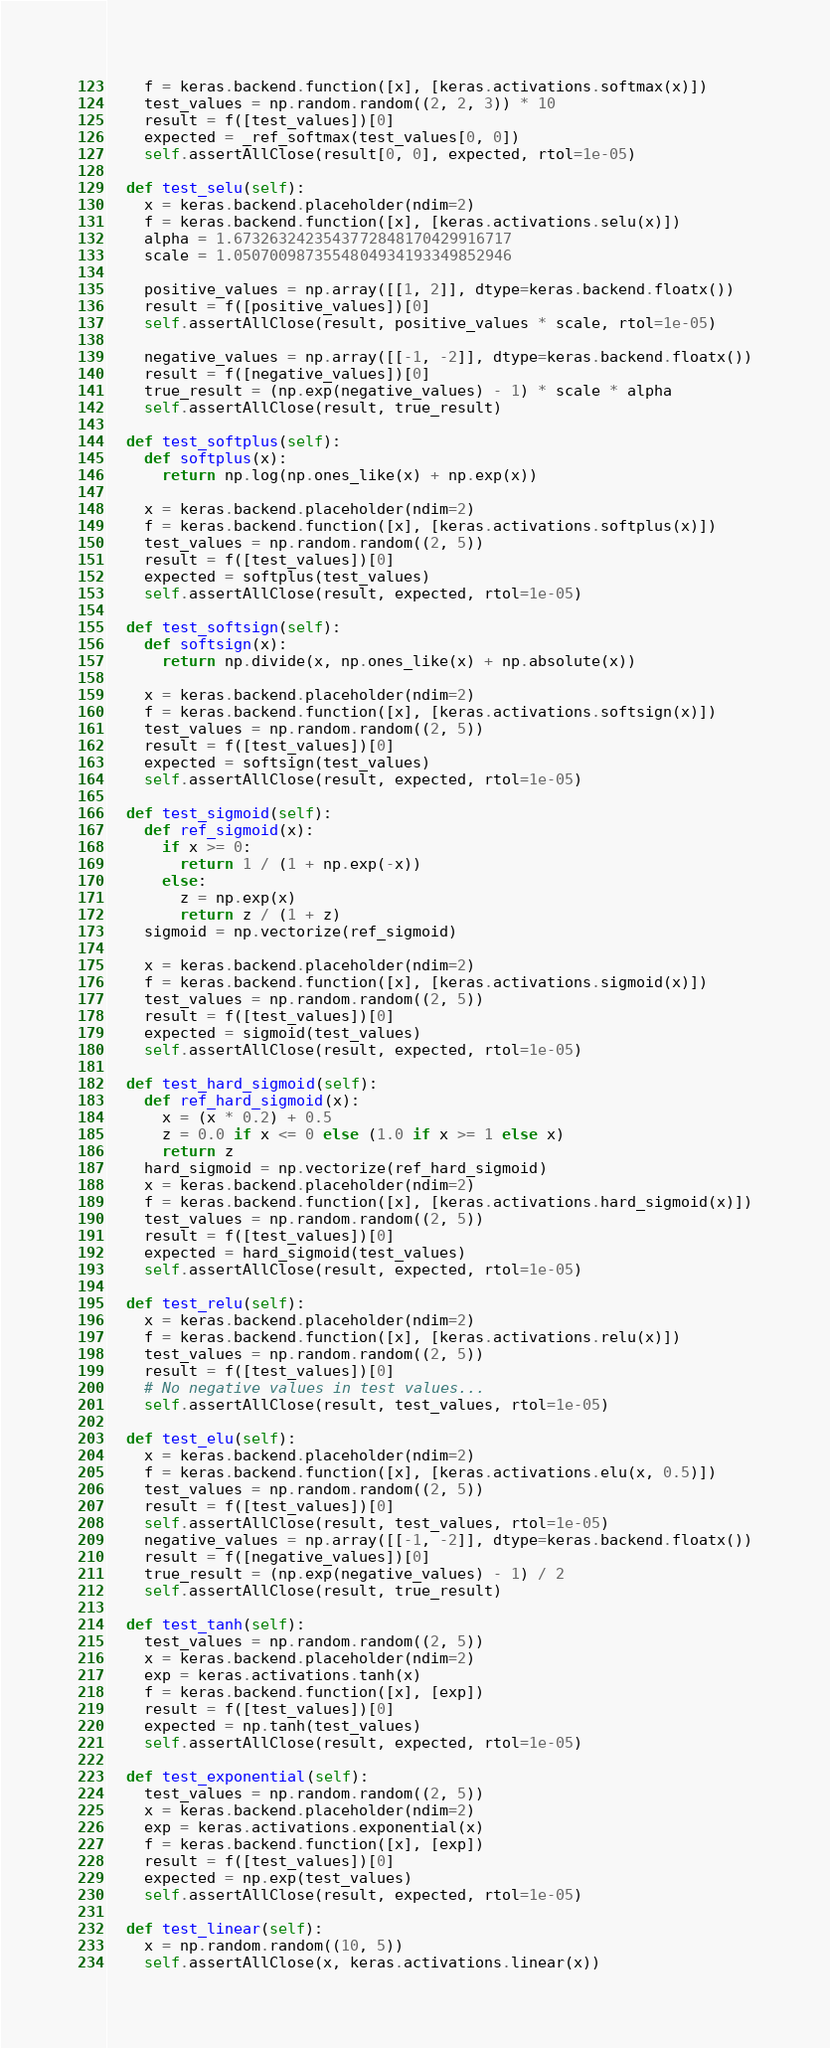Convert code to text. <code><loc_0><loc_0><loc_500><loc_500><_Python_>    f = keras.backend.function([x], [keras.activations.softmax(x)])
    test_values = np.random.random((2, 2, 3)) * 10
    result = f([test_values])[0]
    expected = _ref_softmax(test_values[0, 0])
    self.assertAllClose(result[0, 0], expected, rtol=1e-05)

  def test_selu(self):
    x = keras.backend.placeholder(ndim=2)
    f = keras.backend.function([x], [keras.activations.selu(x)])
    alpha = 1.6732632423543772848170429916717
    scale = 1.0507009873554804934193349852946

    positive_values = np.array([[1, 2]], dtype=keras.backend.floatx())
    result = f([positive_values])[0]
    self.assertAllClose(result, positive_values * scale, rtol=1e-05)

    negative_values = np.array([[-1, -2]], dtype=keras.backend.floatx())
    result = f([negative_values])[0]
    true_result = (np.exp(negative_values) - 1) * scale * alpha
    self.assertAllClose(result, true_result)

  def test_softplus(self):
    def softplus(x):
      return np.log(np.ones_like(x) + np.exp(x))

    x = keras.backend.placeholder(ndim=2)
    f = keras.backend.function([x], [keras.activations.softplus(x)])
    test_values = np.random.random((2, 5))
    result = f([test_values])[0]
    expected = softplus(test_values)
    self.assertAllClose(result, expected, rtol=1e-05)

  def test_softsign(self):
    def softsign(x):
      return np.divide(x, np.ones_like(x) + np.absolute(x))

    x = keras.backend.placeholder(ndim=2)
    f = keras.backend.function([x], [keras.activations.softsign(x)])
    test_values = np.random.random((2, 5))
    result = f([test_values])[0]
    expected = softsign(test_values)
    self.assertAllClose(result, expected, rtol=1e-05)

  def test_sigmoid(self):
    def ref_sigmoid(x):
      if x >= 0:
        return 1 / (1 + np.exp(-x))
      else:
        z = np.exp(x)
        return z / (1 + z)
    sigmoid = np.vectorize(ref_sigmoid)

    x = keras.backend.placeholder(ndim=2)
    f = keras.backend.function([x], [keras.activations.sigmoid(x)])
    test_values = np.random.random((2, 5))
    result = f([test_values])[0]
    expected = sigmoid(test_values)
    self.assertAllClose(result, expected, rtol=1e-05)

  def test_hard_sigmoid(self):
    def ref_hard_sigmoid(x):
      x = (x * 0.2) + 0.5
      z = 0.0 if x <= 0 else (1.0 if x >= 1 else x)
      return z
    hard_sigmoid = np.vectorize(ref_hard_sigmoid)
    x = keras.backend.placeholder(ndim=2)
    f = keras.backend.function([x], [keras.activations.hard_sigmoid(x)])
    test_values = np.random.random((2, 5))
    result = f([test_values])[0]
    expected = hard_sigmoid(test_values)
    self.assertAllClose(result, expected, rtol=1e-05)

  def test_relu(self):
    x = keras.backend.placeholder(ndim=2)
    f = keras.backend.function([x], [keras.activations.relu(x)])
    test_values = np.random.random((2, 5))
    result = f([test_values])[0]
    # No negative values in test values...
    self.assertAllClose(result, test_values, rtol=1e-05)

  def test_elu(self):
    x = keras.backend.placeholder(ndim=2)
    f = keras.backend.function([x], [keras.activations.elu(x, 0.5)])
    test_values = np.random.random((2, 5))
    result = f([test_values])[0]
    self.assertAllClose(result, test_values, rtol=1e-05)
    negative_values = np.array([[-1, -2]], dtype=keras.backend.floatx())
    result = f([negative_values])[0]
    true_result = (np.exp(negative_values) - 1) / 2
    self.assertAllClose(result, true_result)

  def test_tanh(self):
    test_values = np.random.random((2, 5))
    x = keras.backend.placeholder(ndim=2)
    exp = keras.activations.tanh(x)
    f = keras.backend.function([x], [exp])
    result = f([test_values])[0]
    expected = np.tanh(test_values)
    self.assertAllClose(result, expected, rtol=1e-05)

  def test_exponential(self):
    test_values = np.random.random((2, 5))
    x = keras.backend.placeholder(ndim=2)
    exp = keras.activations.exponential(x)
    f = keras.backend.function([x], [exp])
    result = f([test_values])[0]
    expected = np.exp(test_values)
    self.assertAllClose(result, expected, rtol=1e-05)

  def test_linear(self):
    x = np.random.random((10, 5))
    self.assertAllClose(x, keras.activations.linear(x))
</code> 